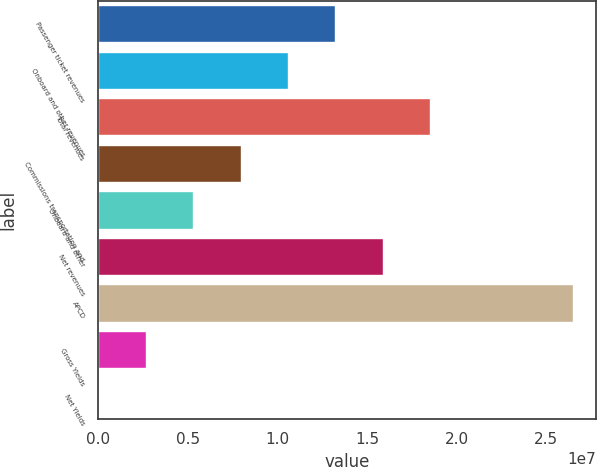<chart> <loc_0><loc_0><loc_500><loc_500><bar_chart><fcel>Passenger ticket revenues<fcel>Onboard and other revenues<fcel>Total revenues<fcel>Commissions transportation and<fcel>Onboard and other<fcel>Net revenues<fcel>APCD<fcel>Gross Yields<fcel>Net Yields<nl><fcel>1.32319e+07<fcel>1.05856e+07<fcel>1.85246e+07<fcel>7.93922e+06<fcel>5.29287e+06<fcel>1.58783e+07<fcel>2.64636e+07<fcel>2.64653e+06<fcel>184.47<nl></chart> 